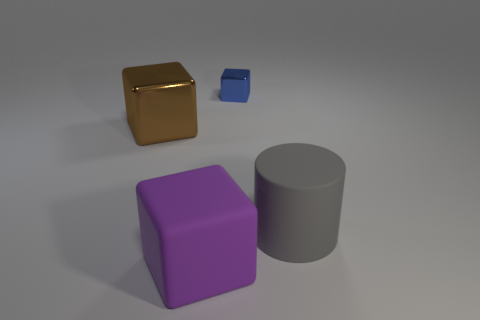Subtract all purple matte blocks. How many blocks are left? 2 Subtract all brown cubes. How many cubes are left? 2 Add 3 large gray objects. How many objects exist? 7 Subtract 2 blocks. How many blocks are left? 1 Subtract all big gray matte cylinders. Subtract all big purple blocks. How many objects are left? 2 Add 4 shiny blocks. How many shiny blocks are left? 6 Add 2 small blue things. How many small blue things exist? 3 Subtract 0 red blocks. How many objects are left? 4 Subtract all cubes. How many objects are left? 1 Subtract all red blocks. Subtract all gray balls. How many blocks are left? 3 